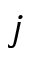Convert formula to latex. <formula><loc_0><loc_0><loc_500><loc_500>j</formula> 